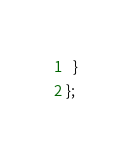<code> <loc_0><loc_0><loc_500><loc_500><_TypeScript_>  }
};
</code> 